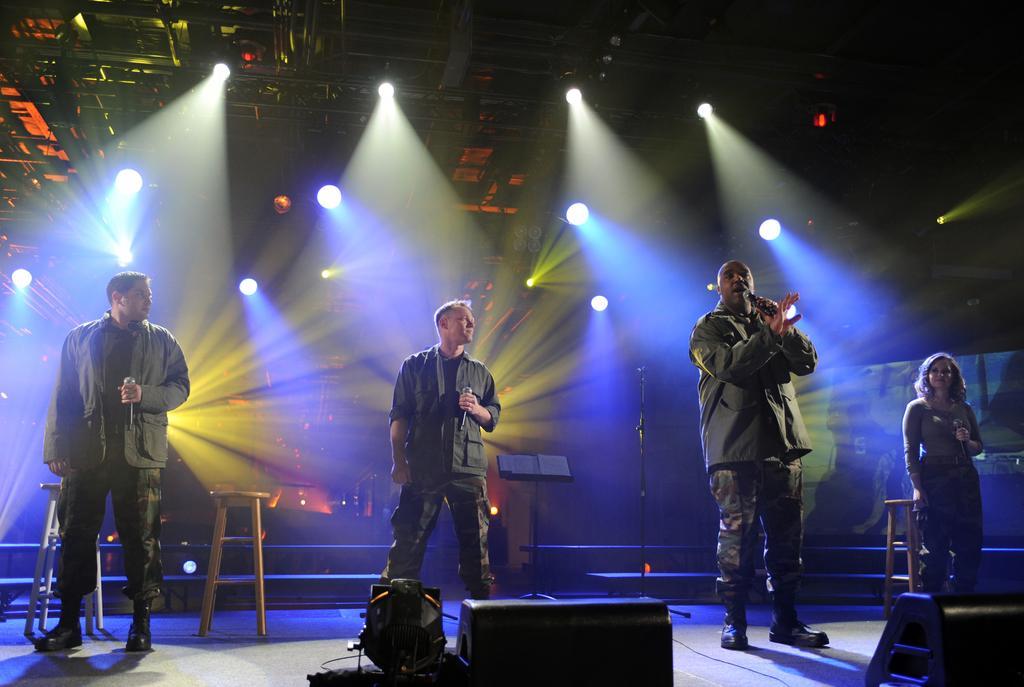Please provide a concise description of this image. In this image I can see few people are standing and holding mics. I can see few lights, speakers, stools, stands and few objects. 